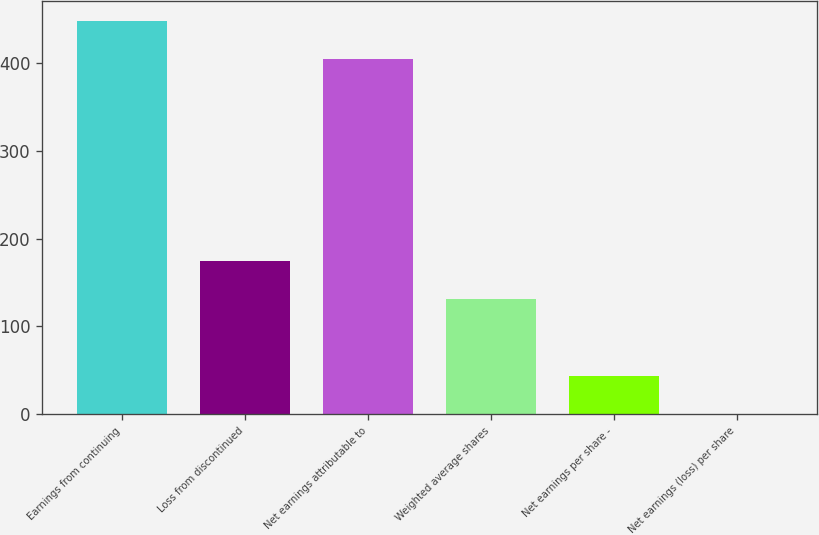Convert chart to OTSL. <chart><loc_0><loc_0><loc_500><loc_500><bar_chart><fcel>Earnings from continuing<fcel>Loss from discontinued<fcel>Net earnings attributable to<fcel>Weighted average shares<fcel>Net earnings per share -<fcel>Net earnings (loss) per share<nl><fcel>448.12<fcel>174.57<fcel>404.5<fcel>130.95<fcel>43.71<fcel>0.09<nl></chart> 